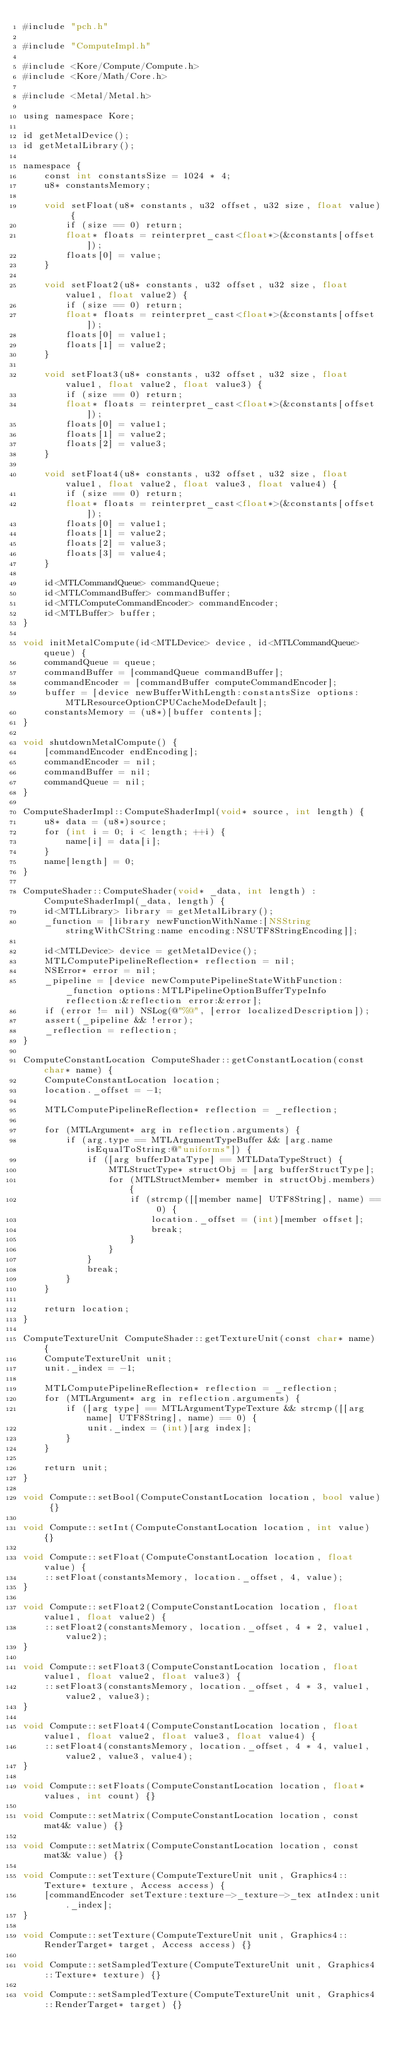<code> <loc_0><loc_0><loc_500><loc_500><_ObjectiveC_>#include "pch.h"

#include "ComputeImpl.h"

#include <Kore/Compute/Compute.h>
#include <Kore/Math/Core.h>

#include <Metal/Metal.h>

using namespace Kore;

id getMetalDevice();
id getMetalLibrary();

namespace {
	const int constantsSize = 1024 * 4;
	u8* constantsMemory;

	void setFloat(u8* constants, u32 offset, u32 size, float value) {
		if (size == 0) return;
		float* floats = reinterpret_cast<float*>(&constants[offset]);
		floats[0] = value;
	}

	void setFloat2(u8* constants, u32 offset, u32 size, float value1, float value2) {
		if (size == 0) return;
		float* floats = reinterpret_cast<float*>(&constants[offset]);
		floats[0] = value1;
		floats[1] = value2;
	}

	void setFloat3(u8* constants, u32 offset, u32 size, float value1, float value2, float value3) {
		if (size == 0) return;
		float* floats = reinterpret_cast<float*>(&constants[offset]);
		floats[0] = value1;
		floats[1] = value2;
		floats[2] = value3;
	}

	void setFloat4(u8* constants, u32 offset, u32 size, float value1, float value2, float value3, float value4) {
		if (size == 0) return;
		float* floats = reinterpret_cast<float*>(&constants[offset]);
		floats[0] = value1;
		floats[1] = value2;
		floats[2] = value3;
		floats[3] = value4;
	}
	
	id<MTLCommandQueue> commandQueue;
	id<MTLCommandBuffer> commandBuffer;
	id<MTLComputeCommandEncoder> commandEncoder;
	id<MTLBuffer> buffer;
}

void initMetalCompute(id<MTLDevice> device, id<MTLCommandQueue> queue) {
	commandQueue = queue;
	commandBuffer = [commandQueue commandBuffer];
	commandEncoder = [commandBuffer computeCommandEncoder];
	buffer = [device newBufferWithLength:constantsSize options:MTLResourceOptionCPUCacheModeDefault];
	constantsMemory = (u8*)[buffer contents];
}

void shutdownMetalCompute() {
	[commandEncoder endEncoding];
	commandEncoder = nil;
	commandBuffer = nil;
	commandQueue = nil;
}

ComputeShaderImpl::ComputeShaderImpl(void* source, int length) {
	u8* data = (u8*)source;
	for (int i = 0; i < length; ++i) {
		name[i] = data[i];
	}
	name[length] = 0;
}

ComputeShader::ComputeShader(void* _data, int length) : ComputeShaderImpl(_data, length) {
	id<MTLLibrary> library = getMetalLibrary();
	_function = [library newFunctionWithName:[NSString stringWithCString:name encoding:NSUTF8StringEncoding]];
	
	id<MTLDevice> device = getMetalDevice();
	MTLComputePipelineReflection* reflection = nil;
	NSError* error = nil;
	_pipeline = [device newComputePipelineStateWithFunction:_function options:MTLPipelineOptionBufferTypeInfo reflection:&reflection error:&error];
	if (error != nil) NSLog(@"%@", [error localizedDescription]);
	assert(_pipeline && !error);
	_reflection = reflection;
}

ComputeConstantLocation ComputeShader::getConstantLocation(const char* name) {
	ComputeConstantLocation location;
	location._offset = -1;
	
	MTLComputePipelineReflection* reflection = _reflection;
	
	for (MTLArgument* arg in reflection.arguments) {
		if (arg.type == MTLArgumentTypeBuffer && [arg.name isEqualToString:@"uniforms"]) {
			if ([arg bufferDataType] == MTLDataTypeStruct) {
				MTLStructType* structObj = [arg bufferStructType];
				for (MTLStructMember* member in structObj.members) {
					if (strcmp([[member name] UTF8String], name) == 0) {
						location._offset = (int)[member offset];
						break;
					}
				}
			}
			break;
		}
	}
	
	return location;
}

ComputeTextureUnit ComputeShader::getTextureUnit(const char* name) {
	ComputeTextureUnit unit;
	unit._index = -1;
	
	MTLComputePipelineReflection* reflection = _reflection;
	for (MTLArgument* arg in reflection.arguments) {
		if ([arg type] == MTLArgumentTypeTexture && strcmp([[arg name] UTF8String], name) == 0) {
			unit._index = (int)[arg index];
		}
	}
	
	return unit;
}

void Compute::setBool(ComputeConstantLocation location, bool value) {}

void Compute::setInt(ComputeConstantLocation location, int value) {}

void Compute::setFloat(ComputeConstantLocation location, float value) {
	::setFloat(constantsMemory, location._offset, 4, value);
}

void Compute::setFloat2(ComputeConstantLocation location, float value1, float value2) {
	::setFloat2(constantsMemory, location._offset, 4 * 2, value1, value2);
}

void Compute::setFloat3(ComputeConstantLocation location, float value1, float value2, float value3) {
	::setFloat3(constantsMemory, location._offset, 4 * 3, value1, value2, value3);
}

void Compute::setFloat4(ComputeConstantLocation location, float value1, float value2, float value3, float value4) {
	::setFloat4(constantsMemory, location._offset, 4 * 4, value1, value2, value3, value4);
}

void Compute::setFloats(ComputeConstantLocation location, float* values, int count) {}

void Compute::setMatrix(ComputeConstantLocation location, const mat4& value) {}

void Compute::setMatrix(ComputeConstantLocation location, const mat3& value) {}

void Compute::setTexture(ComputeTextureUnit unit, Graphics4::Texture* texture, Access access) {
	[commandEncoder setTexture:texture->_texture->_tex atIndex:unit._index];
}

void Compute::setTexture(ComputeTextureUnit unit, Graphics4::RenderTarget* target, Access access) {}

void Compute::setSampledTexture(ComputeTextureUnit unit, Graphics4::Texture* texture) {}

void Compute::setSampledTexture(ComputeTextureUnit unit, Graphics4::RenderTarget* target) {}
</code> 